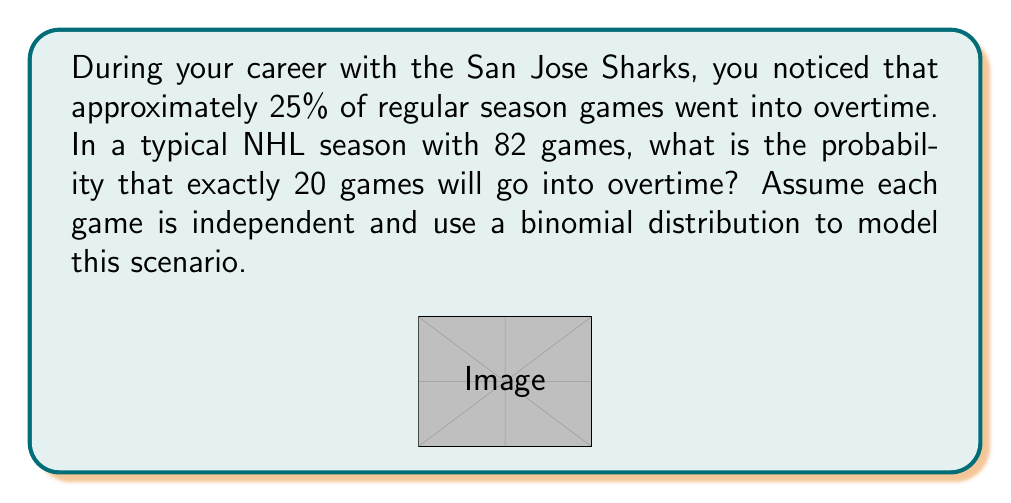Teach me how to tackle this problem. To solve this problem, we'll use the binomial distribution formula:

$$P(X = k) = \binom{n}{k} p^k (1-p)^{n-k}$$

Where:
- $n$ is the number of trials (games in a season)
- $k$ is the number of successes (games going into overtime)
- $p$ is the probability of success on each trial

Given:
- $n = 82$ (games in a season)
- $k = 20$ (games we want to go into overtime)
- $p = 0.25$ (probability of a game going into overtime)

Step 1: Calculate the binomial coefficient
$$\binom{82}{20} = \frac{82!}{20!(82-20)!} = \frac{82!}{20!62!}$$

Step 2: Substitute values into the binomial distribution formula
$$P(X = 20) = \binom{82}{20} (0.25)^{20} (1-0.25)^{82-20}$$

Step 3: Simplify
$$P(X = 20) = \binom{82}{20} (0.25)^{20} (0.75)^{62}$$

Step 4: Calculate using a calculator or computer
$$P(X = 20) \approx 0.0874$$

Therefore, the probability of exactly 20 games going into overtime in an 82-game season is approximately 0.0874 or 8.74%.
Answer: 0.0874 (or 8.74%) 